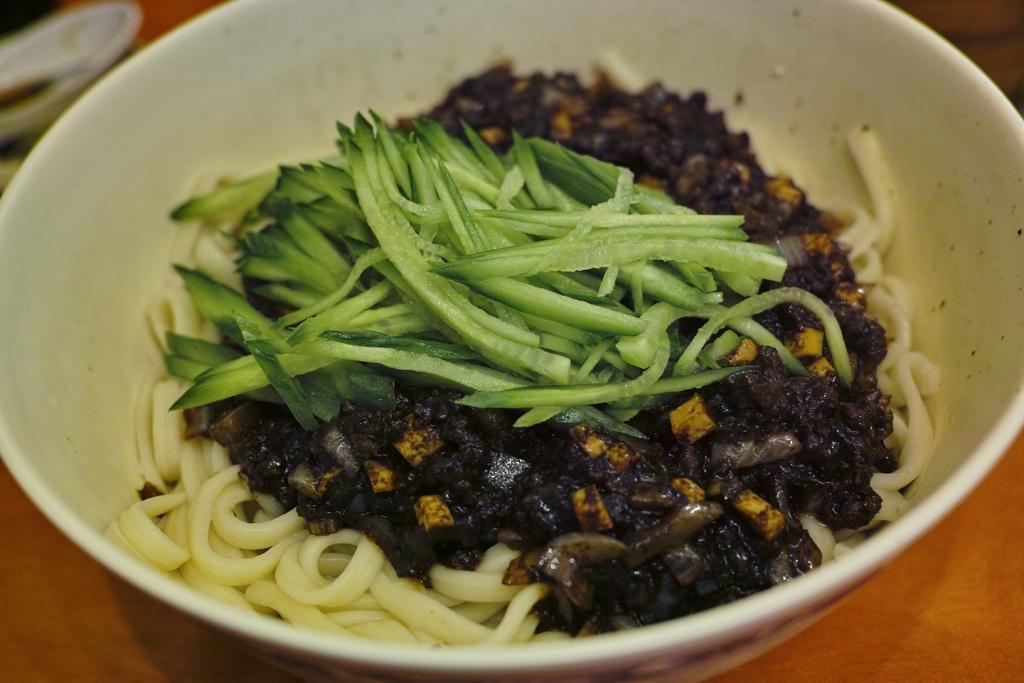In one or two sentences, can you explain what this image depicts? In this image we can see the food item in the bowl which is placed on a wooden surface. 